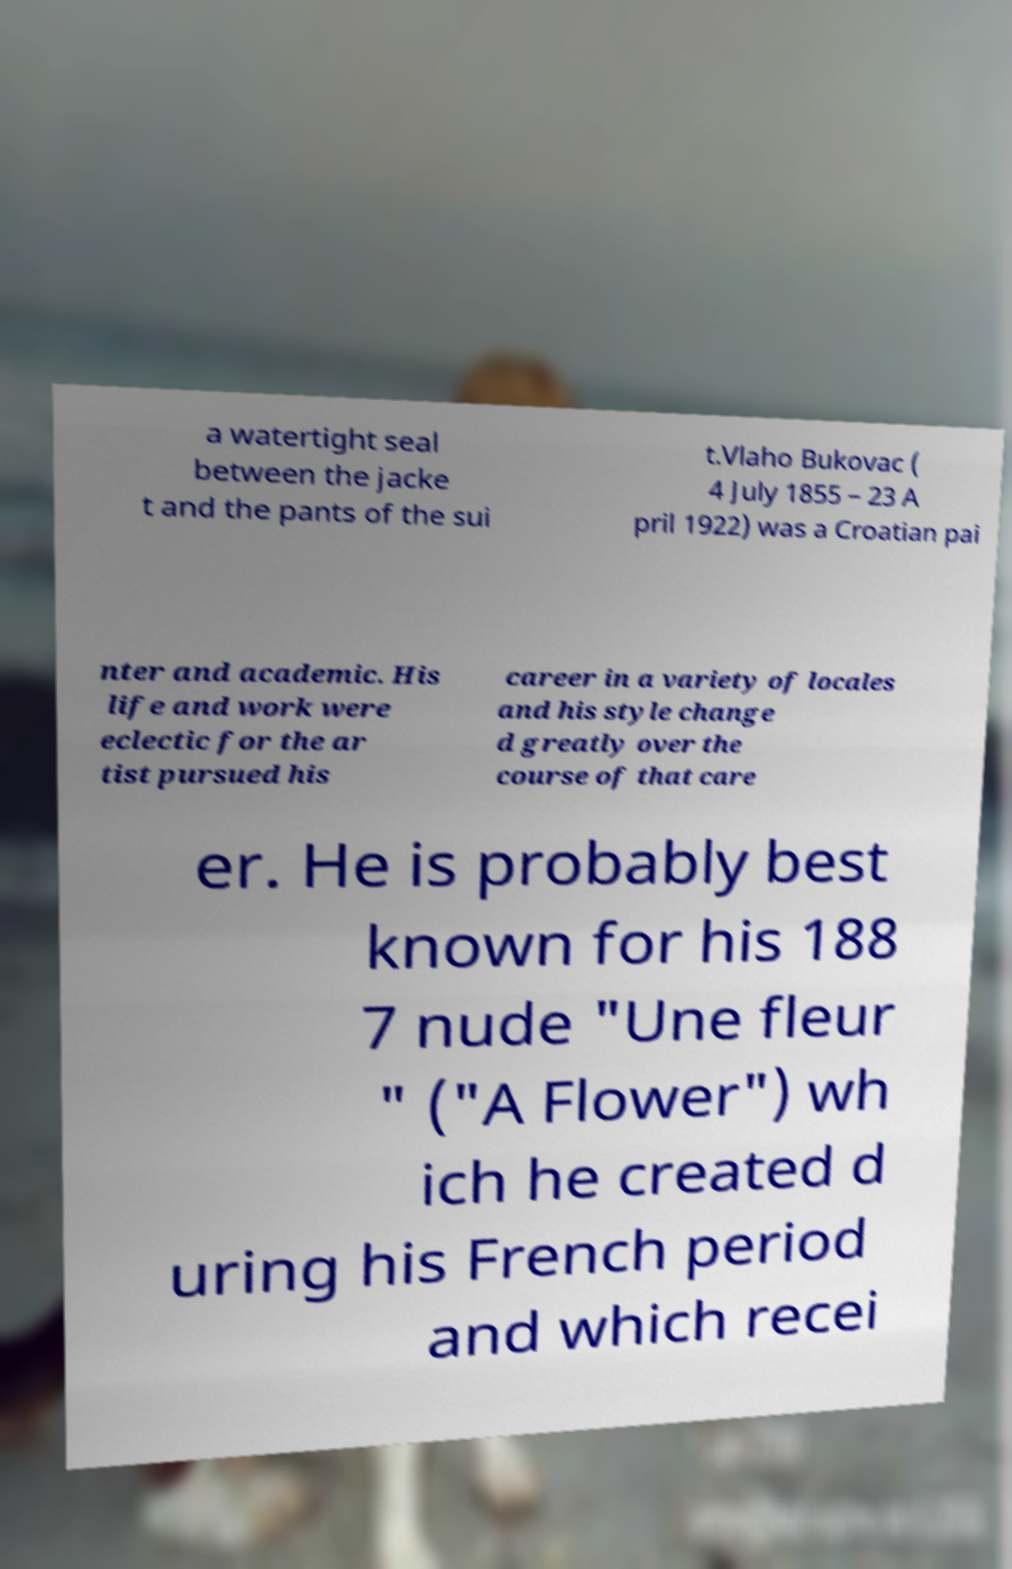For documentation purposes, I need the text within this image transcribed. Could you provide that? a watertight seal between the jacke t and the pants of the sui t.Vlaho Bukovac ( 4 July 1855 – 23 A pril 1922) was a Croatian pai nter and academic. His life and work were eclectic for the ar tist pursued his career in a variety of locales and his style change d greatly over the course of that care er. He is probably best known for his 188 7 nude "Une fleur " ("A Flower") wh ich he created d uring his French period and which recei 